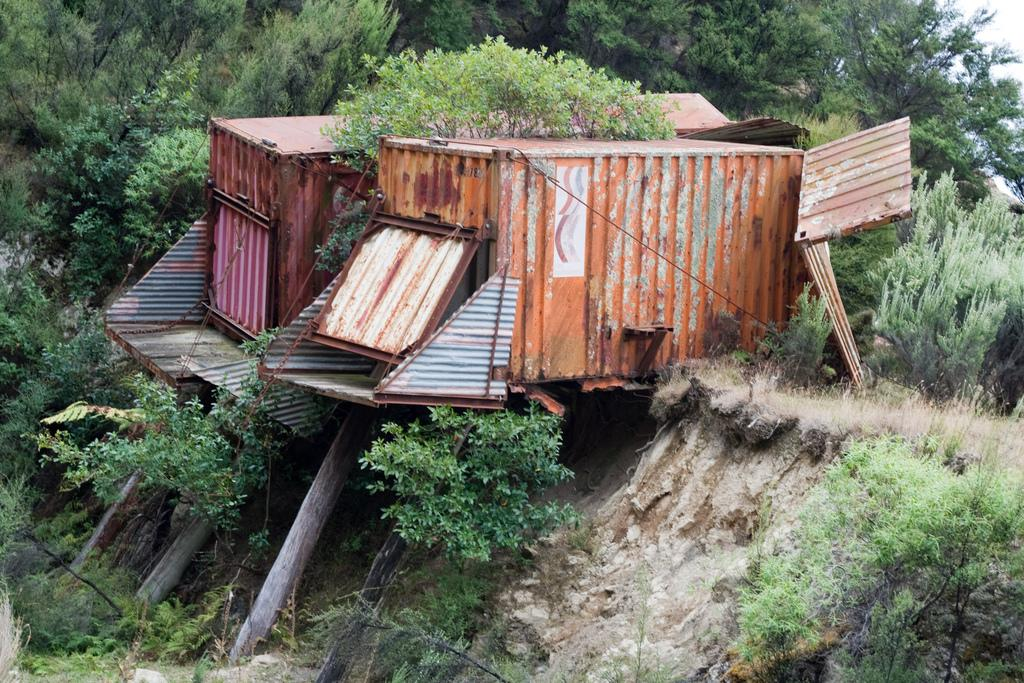What type of structures can be seen in the image? There are sheds in the image. What else is present in the image besides the sheds? There are plants, wooden poles, and trees in the image. What can be seen in the background of the image? The sky is visible in the background of the image. What property does the control panel in the image manage? There is no control panel present in the image; it features sheds, plants, wooden poles, trees, and the sky. 